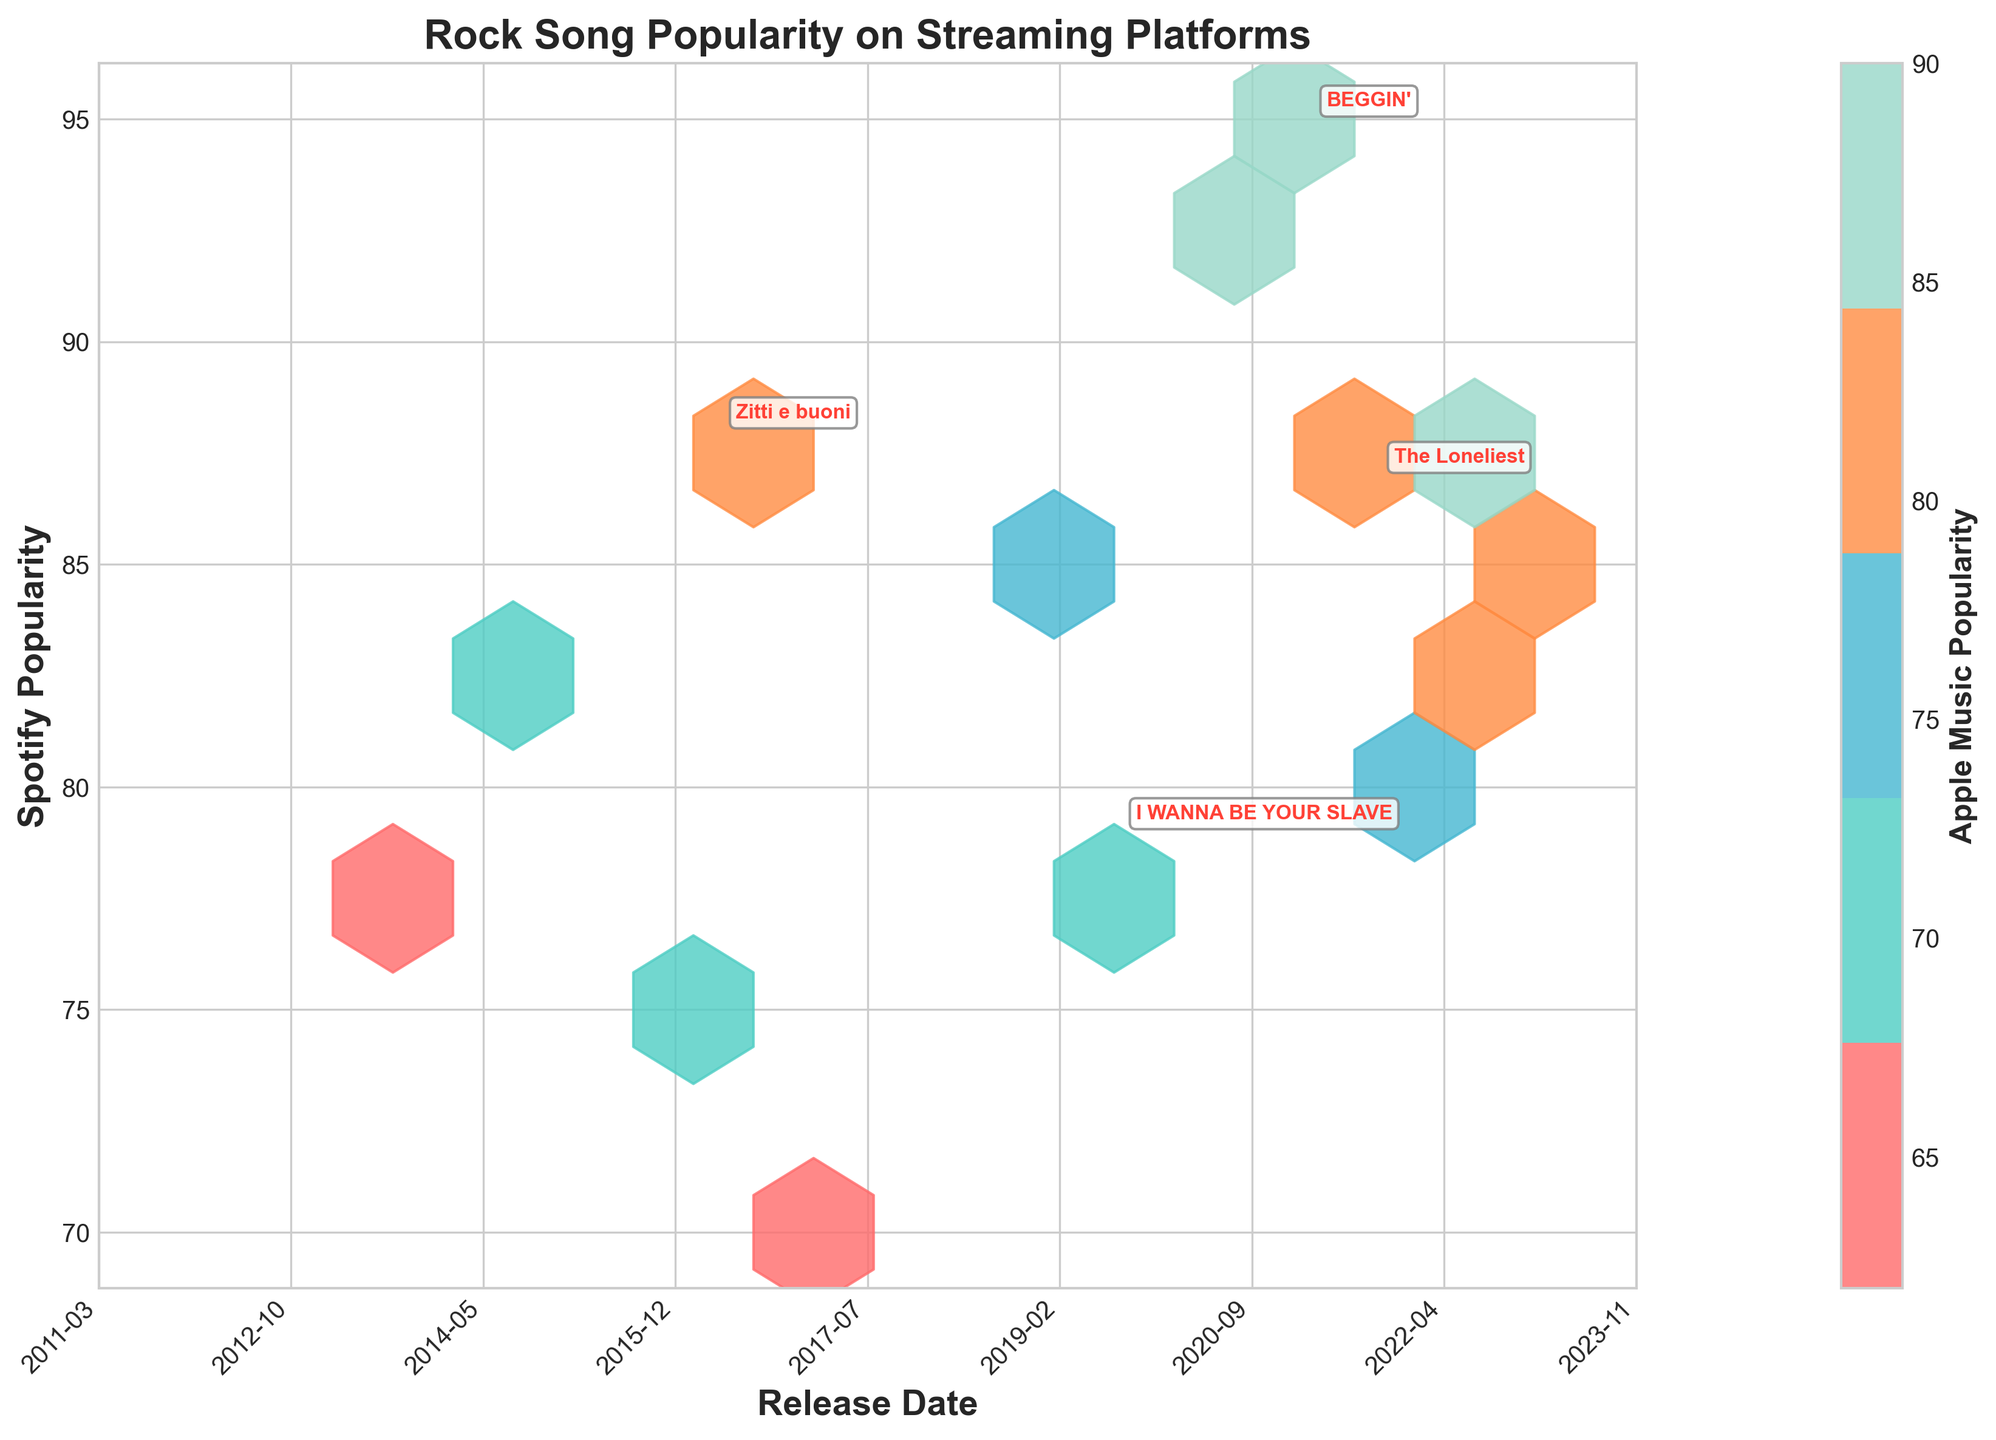What is the title of the plot? The title is positioned at the top of the plot and states the main subject visually represented.
Answer: Rock Song Popularity on Streaming Platforms Which streaming platform's popularity is indicated by the colorbar? The label on the colorbar, usually positioned next to it, specifies this information.
Answer: Apple Music Popularity What does the x-axis represent, and how are the ticks labeled? The x-axis represents "Release Date" and the ticks are labeled with formatted dates like '2013-01', '2014-01', etc.
Answer: Release Date What is the trend of Måneskin songs on Spotify in terms of popularity? Each Måneskin song is annotated with its title on the plot. Their Spotify Popularity values are presented along the y-axis.
Answer: Måneskin songs generally show high Spotify popularity values How many different release dates are shown in the hexbin plot? Counting the unique tick labels along the x-axis will give this value.
Answer: 14 What can be inferred about the relationship between Spotify and Apple Music Popularity for songs released after 2019? Examine hexbin cells in the corresponding x-axis region and compare high-popularity areas.
Answer: Both popularities tend to be high for songs released after 2019 Which song has the highest Spotify Popularity, and what is its value? Find the point with the maximum y-axis value and check its label or annotations.
Answer: Watermelon Sugar, 92 How do the popularity correlations for songs released between 2017 and 2019 compare on Spotify and Apple Music? Observe hexbin densities and compare the colors between cells corresponding to these years. More intense colors indicate higher correlations.
Answer: These songs show moderately high popularity on both platforms What is the range of Apple Music Popularity indicated on the colorbar? The colorbar ranges are visually annotated, often from the bottom to the top of the bar.
Answer: 60 to 90 